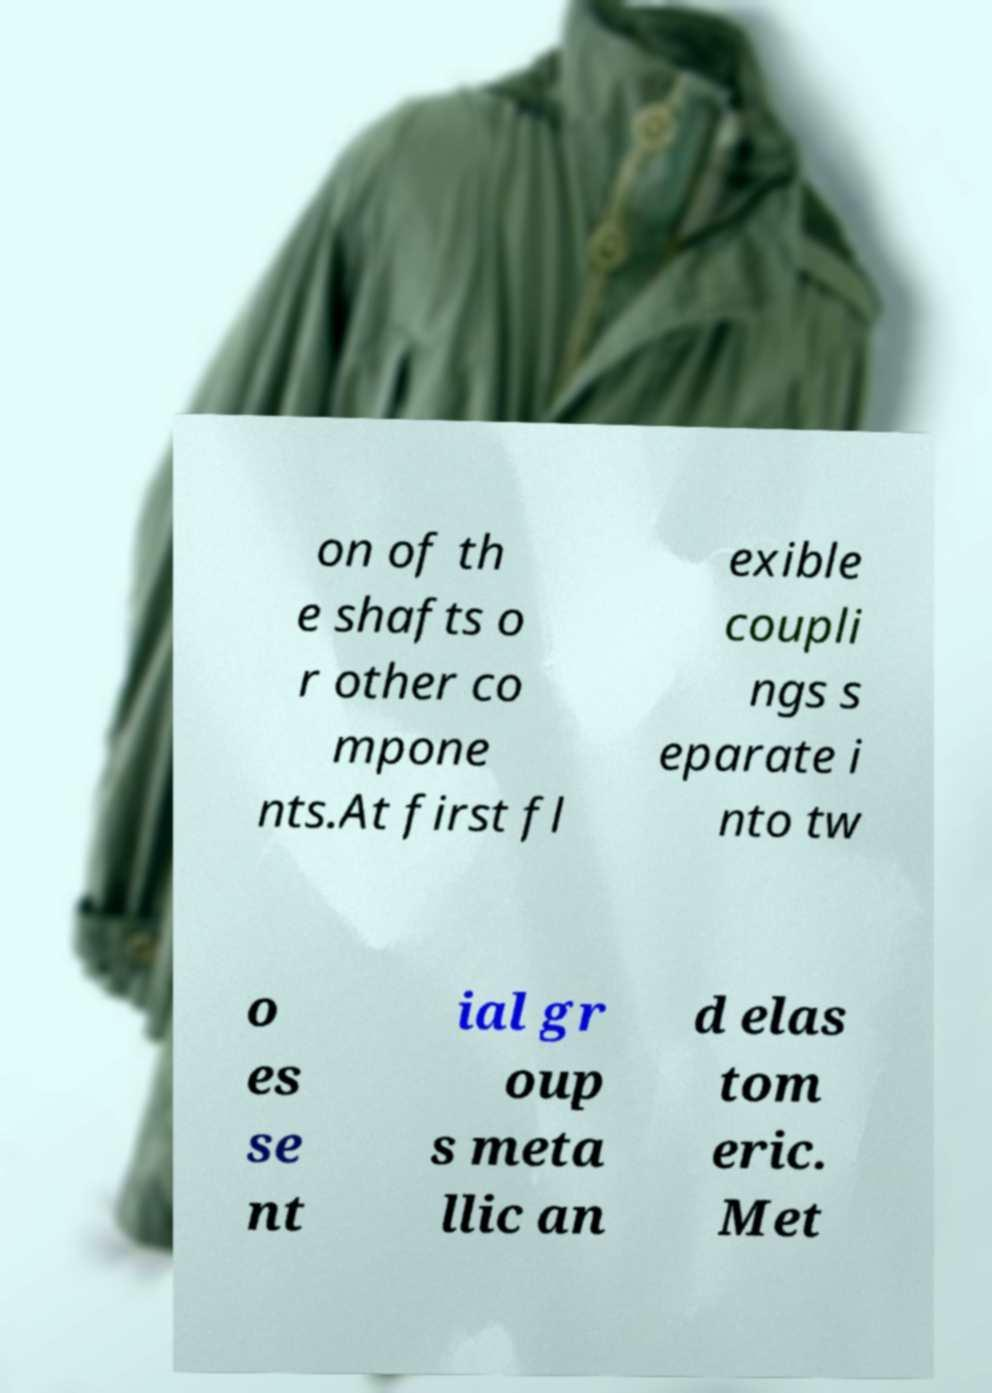Could you assist in decoding the text presented in this image and type it out clearly? on of th e shafts o r other co mpone nts.At first fl exible coupli ngs s eparate i nto tw o es se nt ial gr oup s meta llic an d elas tom eric. Met 